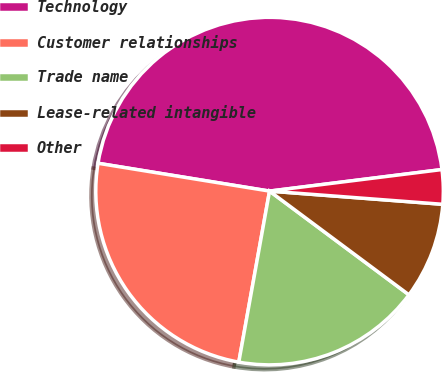<chart> <loc_0><loc_0><loc_500><loc_500><pie_chart><fcel>Technology<fcel>Customer relationships<fcel>Trade name<fcel>Lease-related intangible<fcel>Other<nl><fcel>45.46%<fcel>24.73%<fcel>17.65%<fcel>8.97%<fcel>3.19%<nl></chart> 